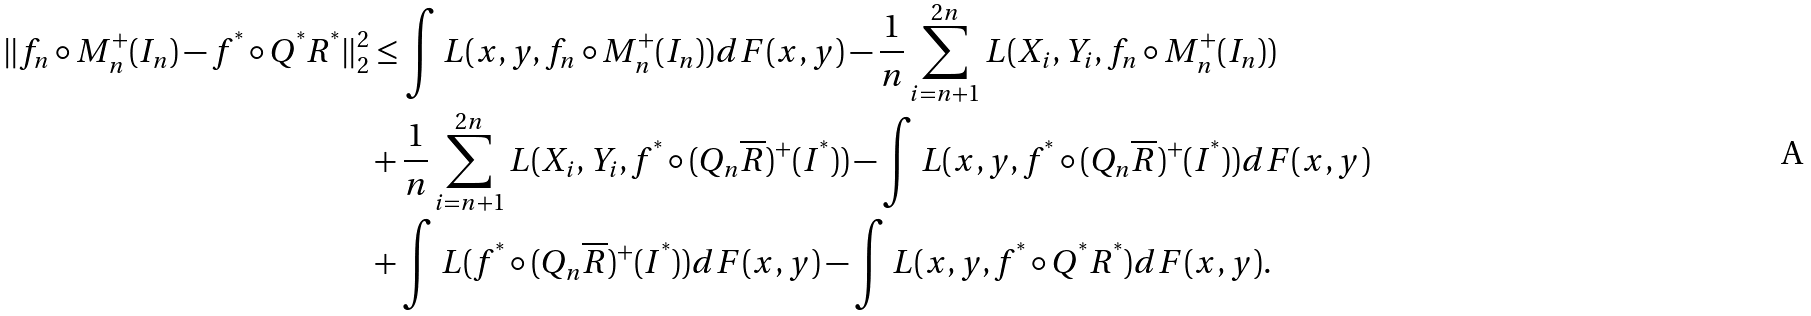Convert formula to latex. <formula><loc_0><loc_0><loc_500><loc_500>\| f _ { n } \circ M _ { n } ^ { + } ( I _ { n } ) - f ^ { ^ { * } } \circ Q ^ { ^ { * } } R ^ { ^ { * } } \| _ { 2 } ^ { 2 } & \leq \int L ( x , y , f _ { n } \circ M _ { n } ^ { + } ( I _ { n } ) ) d F ( x , y ) - \frac { 1 } { n } \sum _ { i = n + 1 } ^ { 2 n } L ( X _ { i } , Y _ { i } , f _ { n } \circ M _ { n } ^ { + } ( I _ { n } ) ) \\ & + \frac { 1 } { n } \sum _ { i = n + 1 } ^ { 2 n } L ( X _ { i } , Y _ { i } , f ^ { ^ { * } } \circ ( Q _ { n } \overline { R } ) ^ { + } ( I ^ { ^ { * } } ) ) - \int L ( x , y , f ^ { ^ { * } } \circ ( Q _ { n } \overline { R } ) ^ { + } ( I ^ { ^ { * } } ) ) d F ( x , y ) \\ & + \int L ( f ^ { ^ { * } } \circ ( Q _ { n } \overline { R } ) ^ { + } ( I ^ { ^ { * } } ) ) d F ( x , y ) - \int L ( x , y , f ^ { ^ { * } } \circ Q ^ { ^ { * } } R ^ { ^ { * } } ) d F ( x , y ) .</formula> 